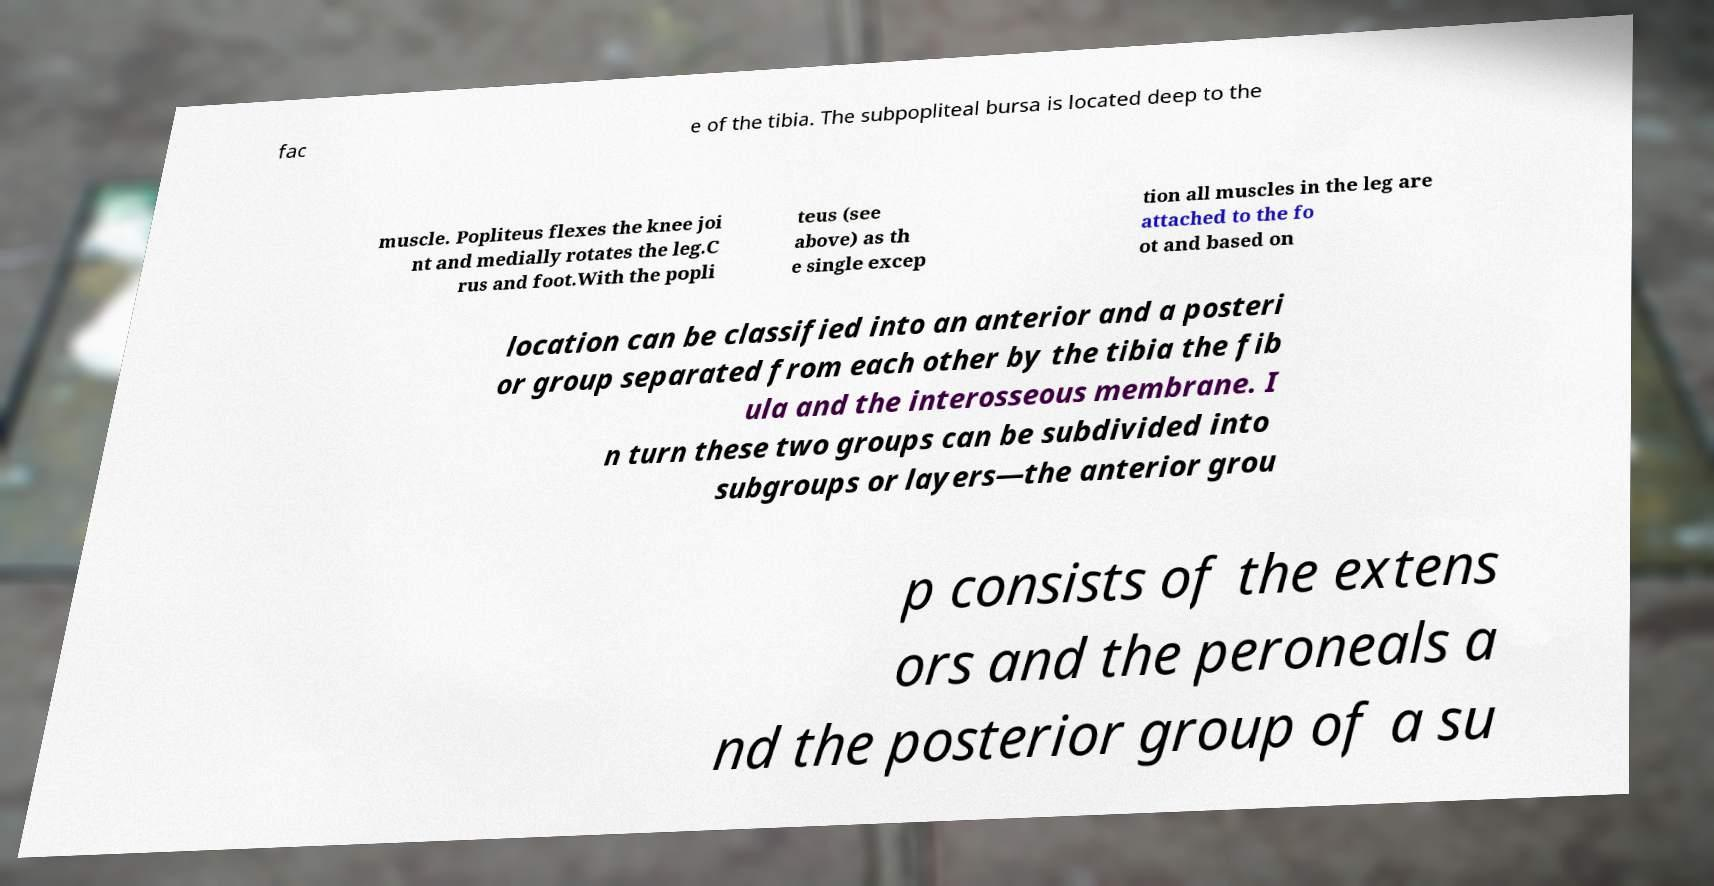Could you extract and type out the text from this image? fac e of the tibia. The subpopliteal bursa is located deep to the muscle. Popliteus flexes the knee joi nt and medially rotates the leg.C rus and foot.With the popli teus (see above) as th e single excep tion all muscles in the leg are attached to the fo ot and based on location can be classified into an anterior and a posteri or group separated from each other by the tibia the fib ula and the interosseous membrane. I n turn these two groups can be subdivided into subgroups or layers—the anterior grou p consists of the extens ors and the peroneals a nd the posterior group of a su 